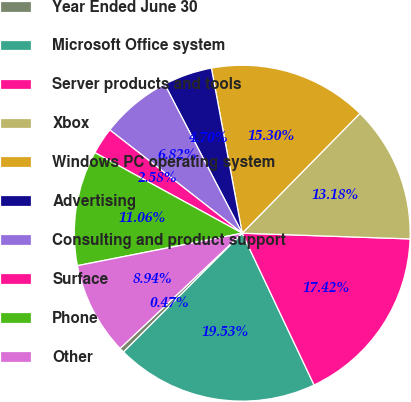Convert chart to OTSL. <chart><loc_0><loc_0><loc_500><loc_500><pie_chart><fcel>Year Ended June 30<fcel>Microsoft Office system<fcel>Server products and tools<fcel>Xbox<fcel>Windows PC operating system<fcel>Advertising<fcel>Consulting and product support<fcel>Surface<fcel>Phone<fcel>Other<nl><fcel>0.47%<fcel>19.53%<fcel>17.42%<fcel>13.18%<fcel>15.3%<fcel>4.7%<fcel>6.82%<fcel>2.58%<fcel>11.06%<fcel>8.94%<nl></chart> 